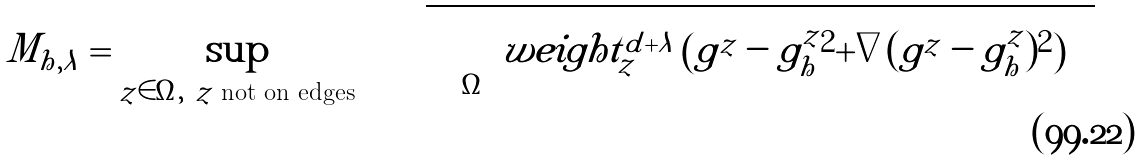Convert formula to latex. <formula><loc_0><loc_0><loc_500><loc_500>M _ { h , \lambda } = \sup _ { z \in \Omega , \ \text {$z$ not on edges} } \quad \sqrt { \int _ { \Omega } \ w e i g h t _ { z } ^ { d + \lambda } \left ( | g ^ { z } - g ^ { z } _ { h } | ^ { 2 } + | \nabla ( g ^ { z } - g ^ { z } _ { h } ) | ^ { 2 } \right ) }</formula> 